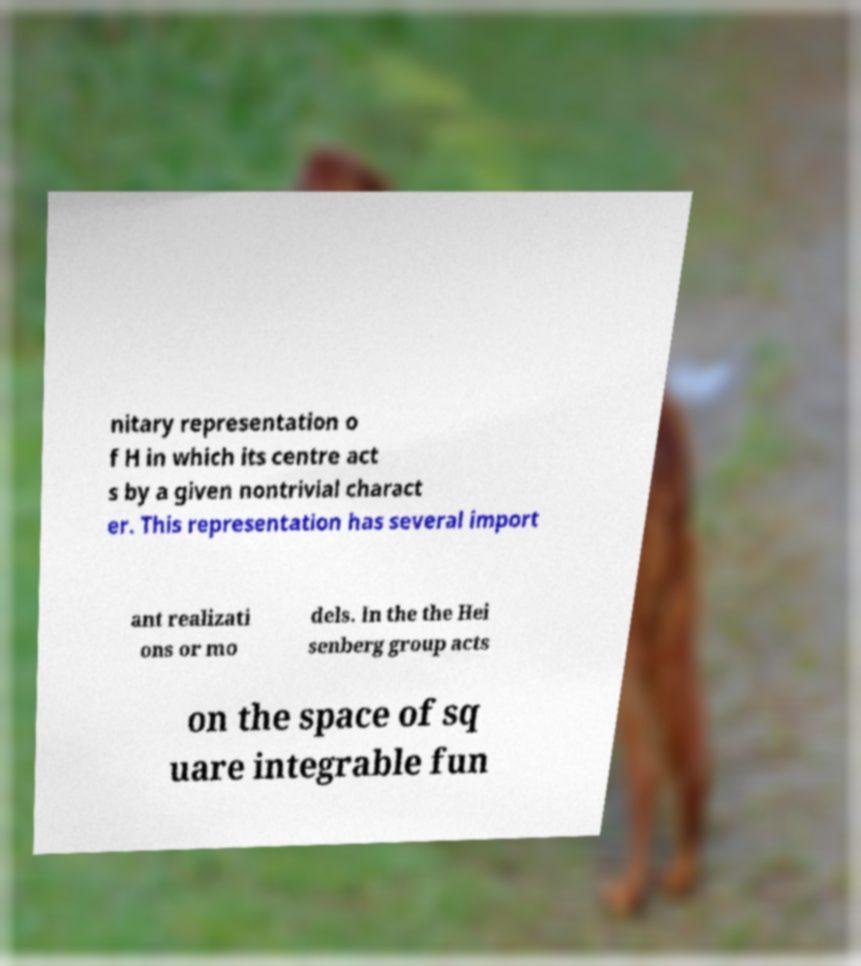There's text embedded in this image that I need extracted. Can you transcribe it verbatim? nitary representation o f H in which its centre act s by a given nontrivial charact er. This representation has several import ant realizati ons or mo dels. In the the Hei senberg group acts on the space of sq uare integrable fun 